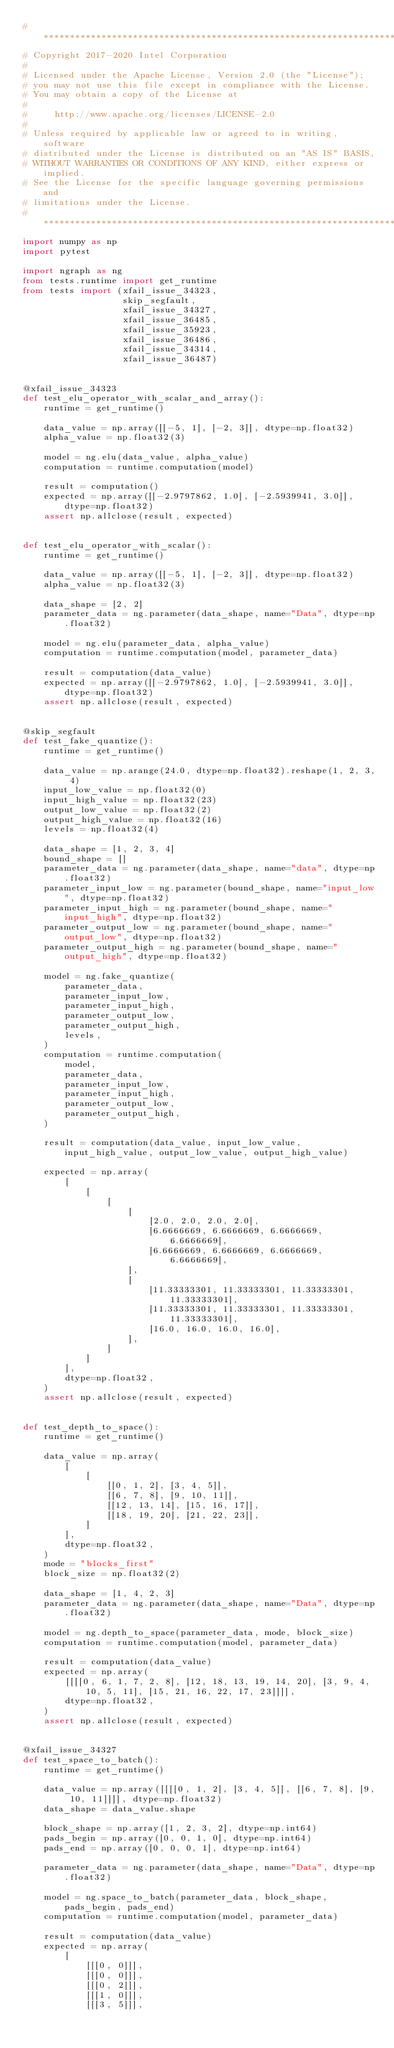Convert code to text. <code><loc_0><loc_0><loc_500><loc_500><_Python_># ******************************************************************************
# Copyright 2017-2020 Intel Corporation
#
# Licensed under the Apache License, Version 2.0 (the "License");
# you may not use this file except in compliance with the License.
# You may obtain a copy of the License at
#
#     http://www.apache.org/licenses/LICENSE-2.0
#
# Unless required by applicable law or agreed to in writing, software
# distributed under the License is distributed on an "AS IS" BASIS,
# WITHOUT WARRANTIES OR CONDITIONS OF ANY KIND, either express or implied.
# See the License for the specific language governing permissions and
# limitations under the License.
# ******************************************************************************
import numpy as np
import pytest

import ngraph as ng
from tests.runtime import get_runtime
from tests import (xfail_issue_34323,
                   skip_segfault,
                   xfail_issue_34327,
                   xfail_issue_36485,
                   xfail_issue_35923,
                   xfail_issue_36486,
                   xfail_issue_34314,
                   xfail_issue_36487)


@xfail_issue_34323
def test_elu_operator_with_scalar_and_array():
    runtime = get_runtime()

    data_value = np.array([[-5, 1], [-2, 3]], dtype=np.float32)
    alpha_value = np.float32(3)

    model = ng.elu(data_value, alpha_value)
    computation = runtime.computation(model)

    result = computation()
    expected = np.array([[-2.9797862, 1.0], [-2.5939941, 3.0]], dtype=np.float32)
    assert np.allclose(result, expected)


def test_elu_operator_with_scalar():
    runtime = get_runtime()

    data_value = np.array([[-5, 1], [-2, 3]], dtype=np.float32)
    alpha_value = np.float32(3)

    data_shape = [2, 2]
    parameter_data = ng.parameter(data_shape, name="Data", dtype=np.float32)

    model = ng.elu(parameter_data, alpha_value)
    computation = runtime.computation(model, parameter_data)

    result = computation(data_value)
    expected = np.array([[-2.9797862, 1.0], [-2.5939941, 3.0]], dtype=np.float32)
    assert np.allclose(result, expected)


@skip_segfault
def test_fake_quantize():
    runtime = get_runtime()

    data_value = np.arange(24.0, dtype=np.float32).reshape(1, 2, 3, 4)
    input_low_value = np.float32(0)
    input_high_value = np.float32(23)
    output_low_value = np.float32(2)
    output_high_value = np.float32(16)
    levels = np.float32(4)

    data_shape = [1, 2, 3, 4]
    bound_shape = []
    parameter_data = ng.parameter(data_shape, name="data", dtype=np.float32)
    parameter_input_low = ng.parameter(bound_shape, name="input_low", dtype=np.float32)
    parameter_input_high = ng.parameter(bound_shape, name="input_high", dtype=np.float32)
    parameter_output_low = ng.parameter(bound_shape, name="output_low", dtype=np.float32)
    parameter_output_high = ng.parameter(bound_shape, name="output_high", dtype=np.float32)

    model = ng.fake_quantize(
        parameter_data,
        parameter_input_low,
        parameter_input_high,
        parameter_output_low,
        parameter_output_high,
        levels,
    )
    computation = runtime.computation(
        model,
        parameter_data,
        parameter_input_low,
        parameter_input_high,
        parameter_output_low,
        parameter_output_high,
    )

    result = computation(data_value, input_low_value, input_high_value, output_low_value, output_high_value)

    expected = np.array(
        [
            [
                [
                    [
                        [2.0, 2.0, 2.0, 2.0],
                        [6.6666669, 6.6666669, 6.6666669, 6.6666669],
                        [6.6666669, 6.6666669, 6.6666669, 6.6666669],
                    ],
                    [
                        [11.33333301, 11.33333301, 11.33333301, 11.33333301],
                        [11.33333301, 11.33333301, 11.33333301, 11.33333301],
                        [16.0, 16.0, 16.0, 16.0],
                    ],
                ]
            ]
        ],
        dtype=np.float32,
    )
    assert np.allclose(result, expected)


def test_depth_to_space():
    runtime = get_runtime()

    data_value = np.array(
        [
            [
                [[0, 1, 2], [3, 4, 5]],
                [[6, 7, 8], [9, 10, 11]],
                [[12, 13, 14], [15, 16, 17]],
                [[18, 19, 20], [21, 22, 23]],
            ]
        ],
        dtype=np.float32,
    )
    mode = "blocks_first"
    block_size = np.float32(2)

    data_shape = [1, 4, 2, 3]
    parameter_data = ng.parameter(data_shape, name="Data", dtype=np.float32)

    model = ng.depth_to_space(parameter_data, mode, block_size)
    computation = runtime.computation(model, parameter_data)

    result = computation(data_value)
    expected = np.array(
        [[[[0, 6, 1, 7, 2, 8], [12, 18, 13, 19, 14, 20], [3, 9, 4, 10, 5, 11], [15, 21, 16, 22, 17, 23]]]],
        dtype=np.float32,
    )
    assert np.allclose(result, expected)


@xfail_issue_34327
def test_space_to_batch():
    runtime = get_runtime()

    data_value = np.array([[[[0, 1, 2], [3, 4, 5]], [[6, 7, 8], [9, 10, 11]]]], dtype=np.float32)
    data_shape = data_value.shape

    block_shape = np.array([1, 2, 3, 2], dtype=np.int64)
    pads_begin = np.array([0, 0, 1, 0], dtype=np.int64)
    pads_end = np.array([0, 0, 0, 1], dtype=np.int64)

    parameter_data = ng.parameter(data_shape, name="Data", dtype=np.float32)

    model = ng.space_to_batch(parameter_data, block_shape, pads_begin, pads_end)
    computation = runtime.computation(model, parameter_data)

    result = computation(data_value)
    expected = np.array(
        [
            [[[0, 0]]],
            [[[0, 0]]],
            [[[0, 2]]],
            [[[1, 0]]],
            [[[3, 5]]],</code> 